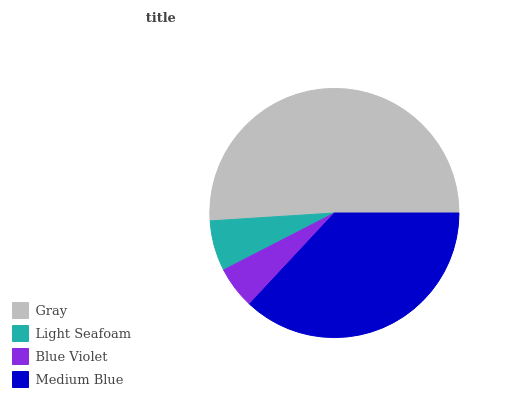Is Blue Violet the minimum?
Answer yes or no. Yes. Is Gray the maximum?
Answer yes or no. Yes. Is Light Seafoam the minimum?
Answer yes or no. No. Is Light Seafoam the maximum?
Answer yes or no. No. Is Gray greater than Light Seafoam?
Answer yes or no. Yes. Is Light Seafoam less than Gray?
Answer yes or no. Yes. Is Light Seafoam greater than Gray?
Answer yes or no. No. Is Gray less than Light Seafoam?
Answer yes or no. No. Is Medium Blue the high median?
Answer yes or no. Yes. Is Light Seafoam the low median?
Answer yes or no. Yes. Is Blue Violet the high median?
Answer yes or no. No. Is Gray the low median?
Answer yes or no. No. 